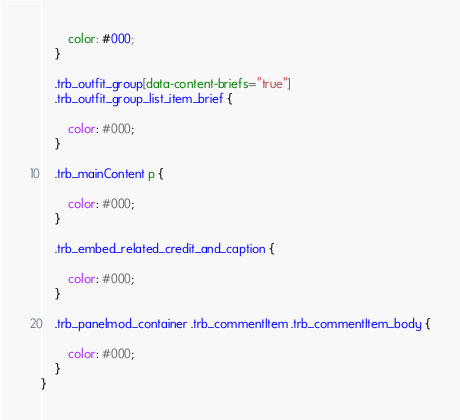Convert code to text. <code><loc_0><loc_0><loc_500><loc_500><_CSS_>        color: #000;
    }

    .trb_outfit_group[data-content-briefs="true"]
    .trb_outfit_group_list_item_brief {

        color: #000;
    }
    
    .trb_mainContent p {

        color: #000;
    }

    .trb_embed_related_credit_and_caption {

        color: #000;
    }

    .trb_panelmod_container .trb_commentItem .trb_commentItem_body {

        color: #000;
    }
}</code> 